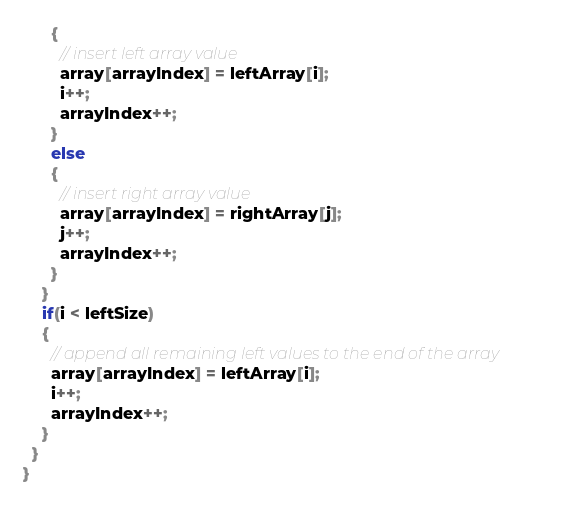Convert code to text. <code><loc_0><loc_0><loc_500><loc_500><_C++_>      {
        // insert left array value
        array[arrayIndex] = leftArray[i];
        i++;
        arrayIndex++;
      }
      else
      {
        // insert right array value
        array[arrayIndex] = rightArray[j];
        j++;
        arrayIndex++;
      }
    }
    if(i < leftSize)
    {
      // append all remaining left values to the end of the array
      array[arrayIndex] = leftArray[i];
      i++;
      arrayIndex++;
    }
  }
}

</code> 